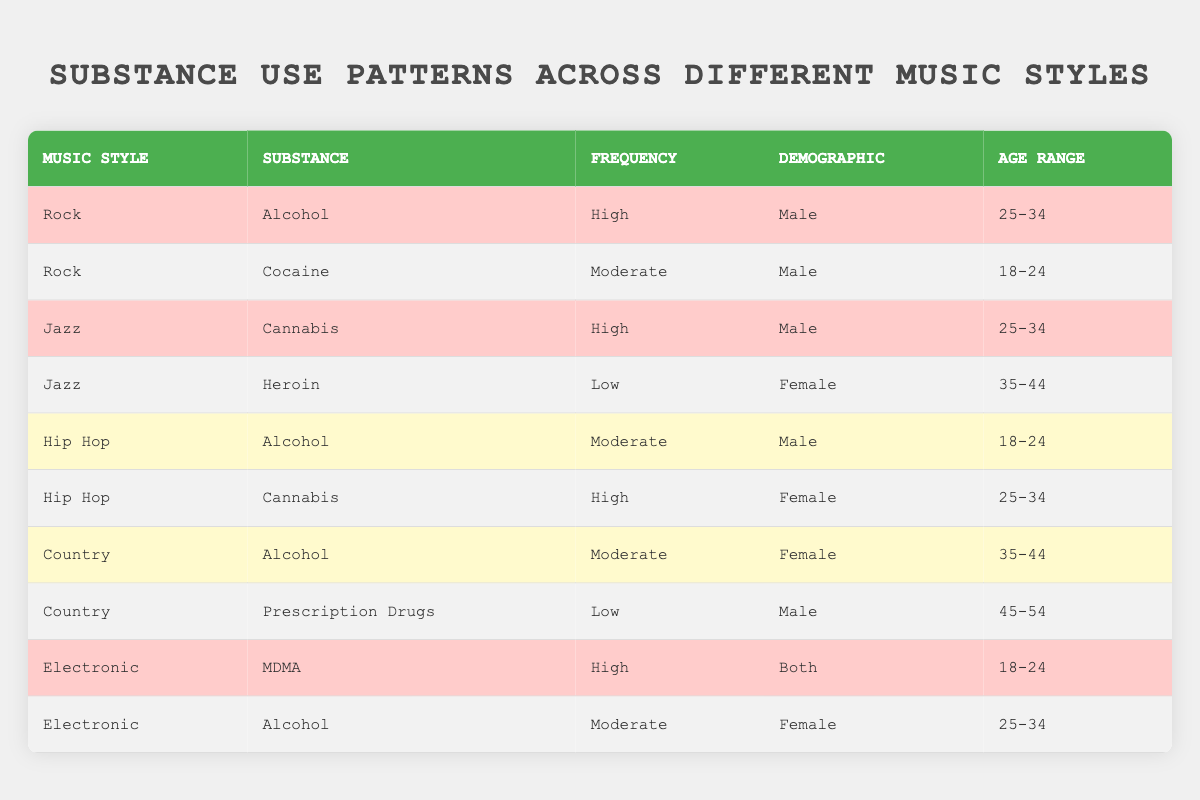What substance has a high frequency of use in Rock music for males aged 25-34? In the table, under the Rock music style, the only substance listed with a high frequency for males aged 25-34 is Alcohol.
Answer: Alcohol How many substances are reported for Jazz music? By reviewing the Jazz section in the table, I see that there are two substances: Cannabis and Heroin.
Answer: 2 Is there a high frequency of alcohol use in Hip Hop for males aged 18-24? Looking at the Hip Hop section, Alcohol is listed with a moderate frequency for males aged 18-24, which means it is not a high frequency.
Answer: No What is the frequency of Cannabis use in Hip Hop for females aged 25-34? The Hip Hop section of the table lists Cannabis with a high frequency specifically for females in the age range of 25-34.
Answer: High Which music style shows low frequency use of a substance by males, and what is that substance? Referring to the Country music style, the table shows the low frequency use of Prescription Drugs by males aged 45-54.
Answer: Country; Prescription Drugs How does the use of Alcohol frequency in Electronic music compare to Rock music? In Electronic music, Alcohol use is at a moderate frequency, whereas in Rock music, it is high. So, Rock music has a higher frequency of Alcohol use than Electronic music.
Answer: Rock music is higher What age range uses MDMA with high frequency, and in which music genre is this substance found? The MDMA substance is found in the Electronic music genre with a high frequency use for the age range of 18-24.
Answer: 18-24; Electronic Is it true that Heroin is used more frequently than Prescription Drugs in the table? Heroin is listed with a low frequency for Jazz, while Prescription Drugs is also low but only appears under Country. Since both are low, there is no comparison that shows one is higher than the other.
Answer: No Which demographic in Jazz has a low frequency of substance use, and what is the substance? In the Jazz section, the demographic of Female has a low frequency of Heroin use, making it the substance in question.
Answer: Female; Heroin 